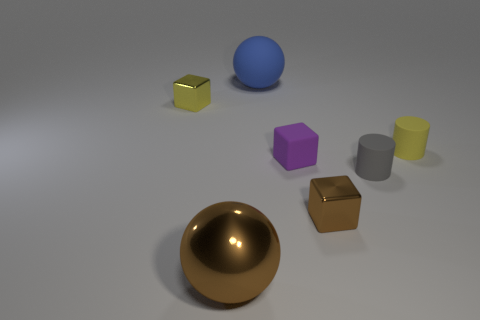What is the shape of the other shiny object that is the same color as the big metal object?
Your answer should be very brief. Cube. Are there fewer small purple matte things left of the rubber block than big cyan shiny blocks?
Your answer should be compact. No. Does the large brown thing have the same shape as the large rubber thing?
Keep it short and to the point. Yes. The yellow object that is made of the same material as the small brown thing is what size?
Your answer should be very brief. Small. Is the number of big shiny things less than the number of tiny rubber cylinders?
Give a very brief answer. Yes. How many big things are either blue rubber cylinders or matte cylinders?
Make the answer very short. 0. What number of shiny things are behind the big brown object and on the right side of the yellow cube?
Your response must be concise. 1. Is the number of blocks greater than the number of big cyan metal cubes?
Provide a short and direct response. Yes. How many other objects are the same shape as the small brown metallic thing?
Your answer should be compact. 2. There is a object that is on the right side of the purple matte object and behind the tiny gray cylinder; what is its material?
Your answer should be compact. Rubber. 